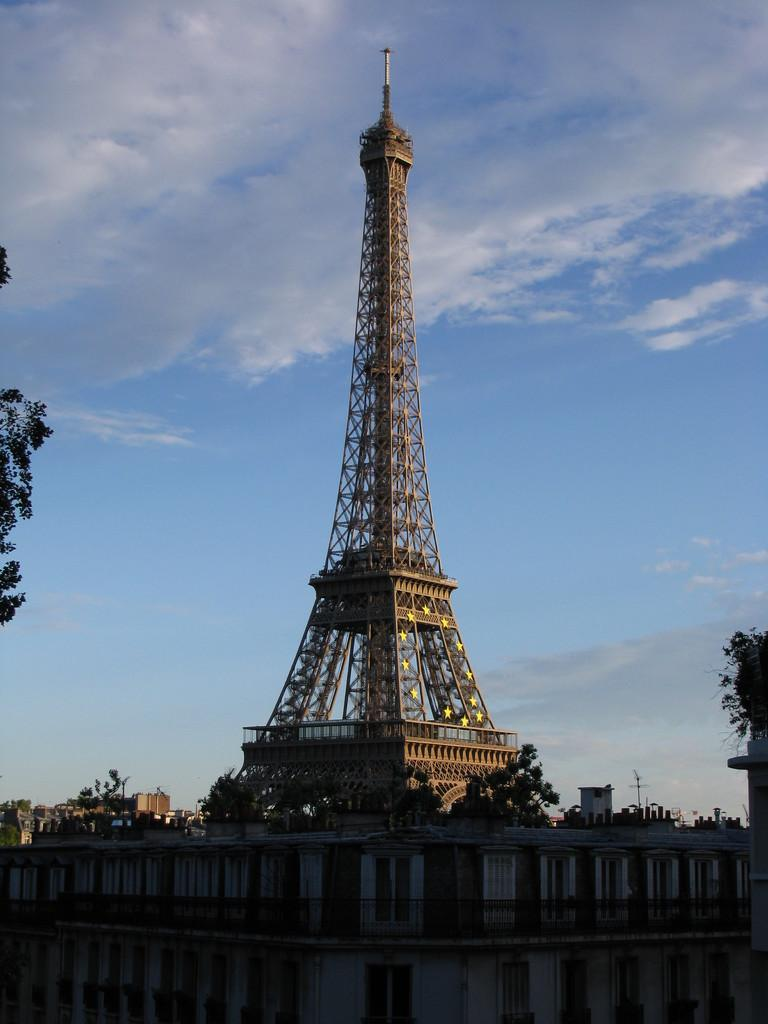What type of structure is in the image? There is a building in the image. What can be seen in the distance behind the building? There is a tower visible in the background of the image. What type of vegetation is present in the image? There are trees present in the image. What type of yam is being harvested in the image? There is no yam present in the image; it features a building, a tower, and trees. 